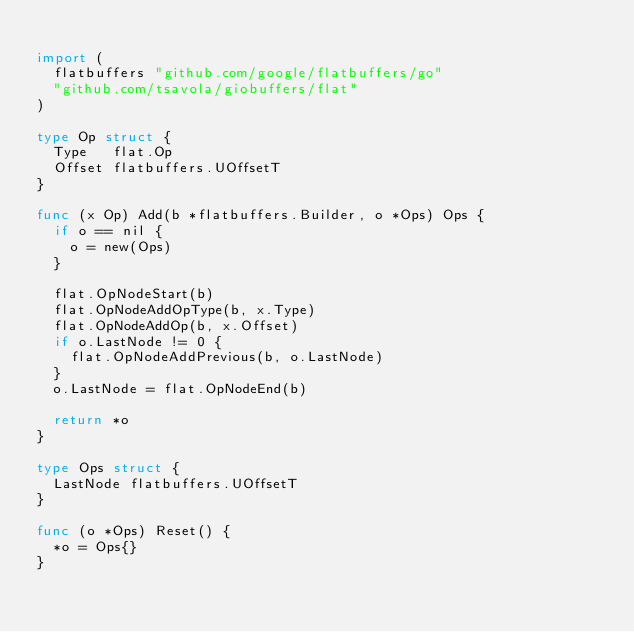Convert code to text. <code><loc_0><loc_0><loc_500><loc_500><_Go_>
import (
	flatbuffers "github.com/google/flatbuffers/go"
	"github.com/tsavola/giobuffers/flat"
)

type Op struct {
	Type   flat.Op
	Offset flatbuffers.UOffsetT
}

func (x Op) Add(b *flatbuffers.Builder, o *Ops) Ops {
	if o == nil {
		o = new(Ops)
	}

	flat.OpNodeStart(b)
	flat.OpNodeAddOpType(b, x.Type)
	flat.OpNodeAddOp(b, x.Offset)
	if o.LastNode != 0 {
		flat.OpNodeAddPrevious(b, o.LastNode)
	}
	o.LastNode = flat.OpNodeEnd(b)

	return *o
}

type Ops struct {
	LastNode flatbuffers.UOffsetT
}

func (o *Ops) Reset() {
	*o = Ops{}
}
</code> 